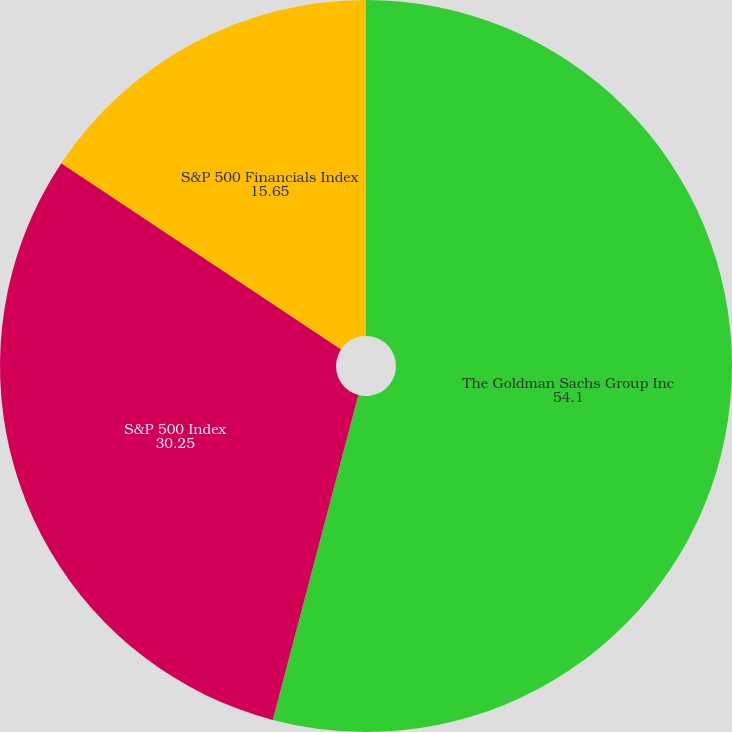Convert chart. <chart><loc_0><loc_0><loc_500><loc_500><pie_chart><fcel>The Goldman Sachs Group Inc<fcel>S&P 500 Index<fcel>S&P 500 Financials Index<nl><fcel>54.1%<fcel>30.25%<fcel>15.65%<nl></chart> 